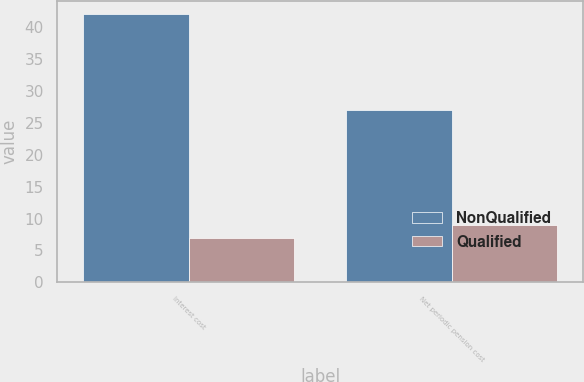Convert chart to OTSL. <chart><loc_0><loc_0><loc_500><loc_500><stacked_bar_chart><ecel><fcel>Interest cost<fcel>Net periodic pension cost<nl><fcel>NonQualified<fcel>42<fcel>27<nl><fcel>Qualified<fcel>7<fcel>9<nl></chart> 